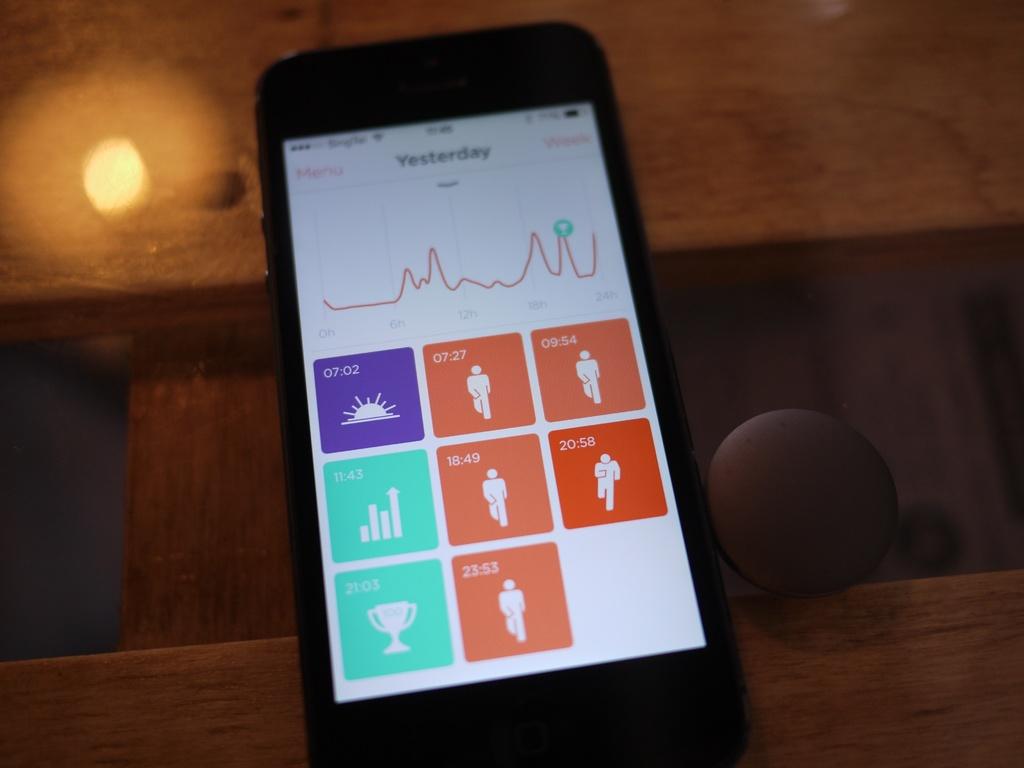Is the clock time visible?
Provide a succinct answer. No. 